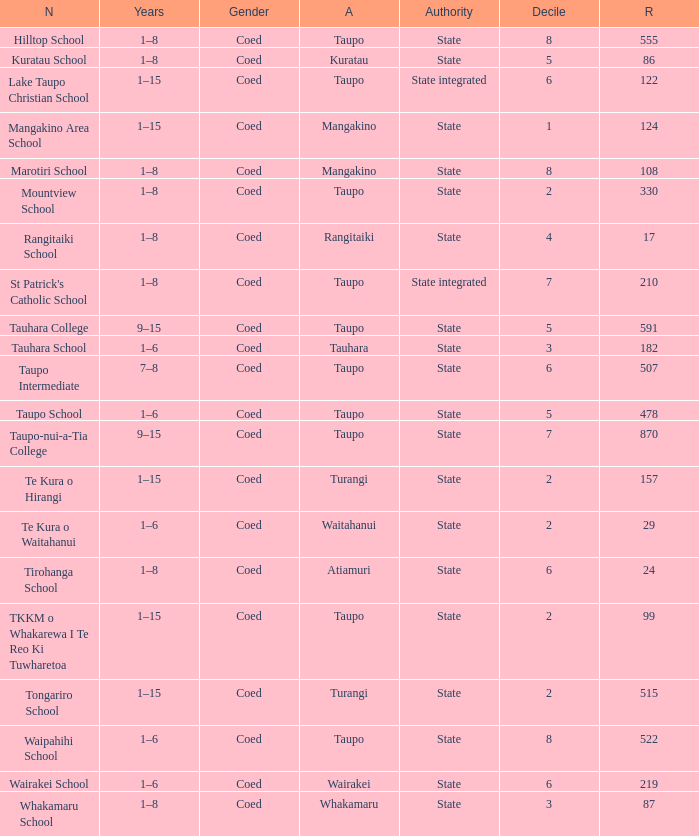Where is the school with state authority that has a roll of more than 157 students? Taupo, Taupo, Taupo, Tauhara, Taupo, Taupo, Taupo, Turangi, Taupo, Wairakei. 